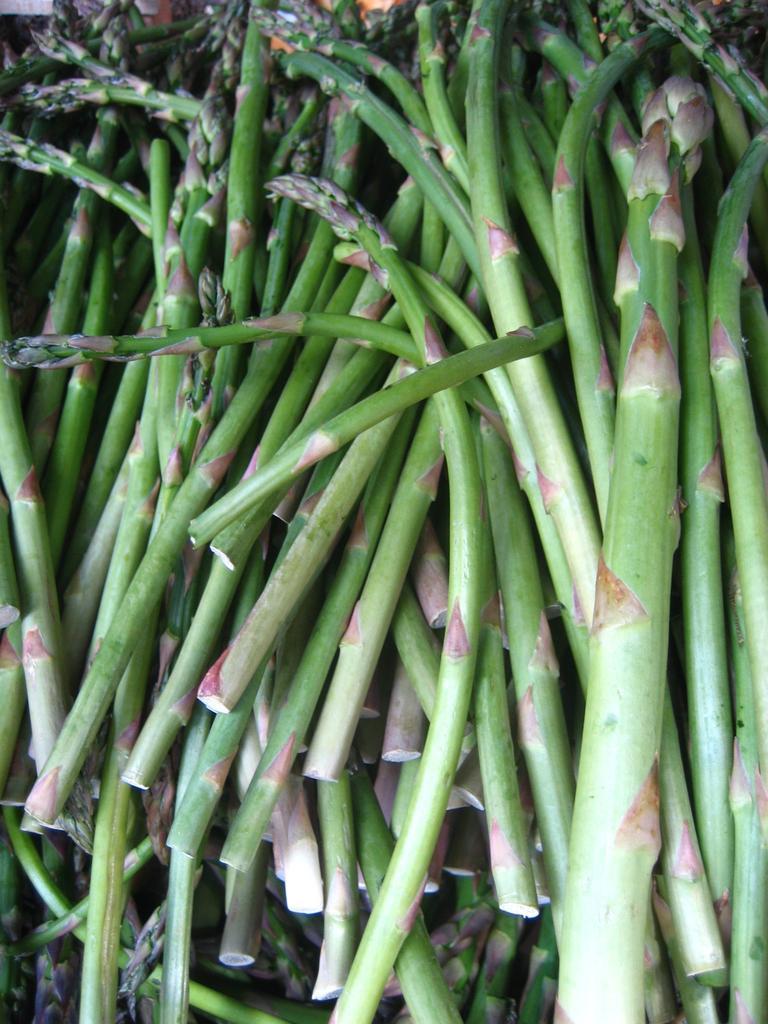What is the primary feature of the image? There are many steps in the image. What can be said about the color of the steps? The steps are green in color. What type of pet can be seen sitting on the steps in the image? There is no pet visible in the image; it only features steps. 